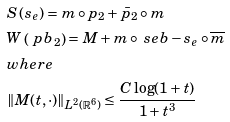Convert formula to latex. <formula><loc_0><loc_0><loc_500><loc_500>& { S } \left ( s _ { e } \right ) = m \circ p _ { 2 } + \bar { p } _ { 2 } \circ m \\ & { W } \left ( \ p b _ { 2 } \right ) = M + m \circ \ s e b - s _ { e } \circ \overline { m } \\ & w h e r e \\ & \| M ( t , \cdot ) \| _ { L ^ { 2 } ( \mathbb { R } ^ { 6 } ) } \leq \frac { C \log ( 1 + t ) } { 1 + t ^ { 3 } }</formula> 